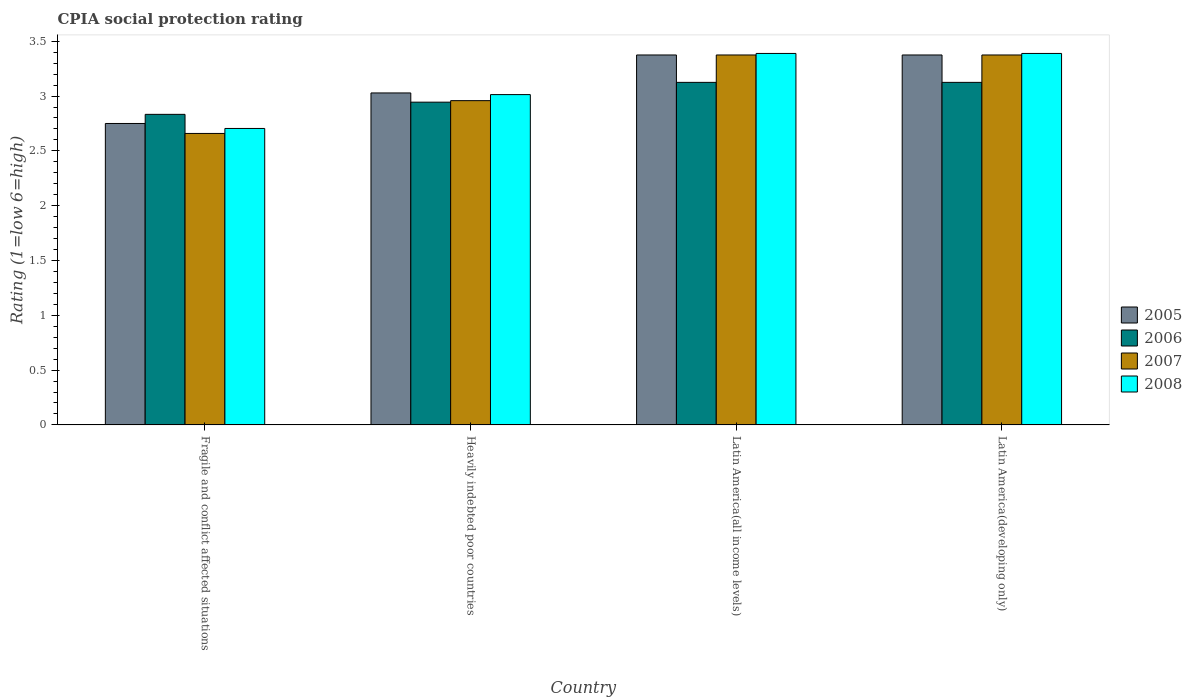How many different coloured bars are there?
Ensure brevity in your answer.  4. How many groups of bars are there?
Offer a very short reply. 4. How many bars are there on the 2nd tick from the left?
Offer a terse response. 4. What is the label of the 3rd group of bars from the left?
Provide a succinct answer. Latin America(all income levels). What is the CPIA rating in 2008 in Latin America(developing only)?
Your answer should be compact. 3.39. Across all countries, what is the maximum CPIA rating in 2006?
Offer a very short reply. 3.12. Across all countries, what is the minimum CPIA rating in 2007?
Make the answer very short. 2.66. In which country was the CPIA rating in 2008 maximum?
Give a very brief answer. Latin America(all income levels). In which country was the CPIA rating in 2007 minimum?
Provide a succinct answer. Fragile and conflict affected situations. What is the total CPIA rating in 2006 in the graph?
Provide a short and direct response. 12.03. What is the difference between the CPIA rating in 2006 in Fragile and conflict affected situations and that in Latin America(all income levels)?
Offer a terse response. -0.29. What is the difference between the CPIA rating in 2005 in Latin America(developing only) and the CPIA rating in 2006 in Heavily indebted poor countries?
Offer a terse response. 0.43. What is the average CPIA rating in 2007 per country?
Give a very brief answer. 3.09. What is the difference between the CPIA rating of/in 2008 and CPIA rating of/in 2005 in Latin America(all income levels)?
Your answer should be very brief. 0.01. What is the ratio of the CPIA rating in 2006 in Heavily indebted poor countries to that in Latin America(all income levels)?
Offer a very short reply. 0.94. Is the CPIA rating in 2007 in Fragile and conflict affected situations less than that in Latin America(all income levels)?
Ensure brevity in your answer.  Yes. Is the difference between the CPIA rating in 2008 in Fragile and conflict affected situations and Heavily indebted poor countries greater than the difference between the CPIA rating in 2005 in Fragile and conflict affected situations and Heavily indebted poor countries?
Offer a very short reply. No. What is the difference between the highest and the second highest CPIA rating in 2008?
Your answer should be compact. -0.38. What is the difference between the highest and the lowest CPIA rating in 2008?
Provide a short and direct response. 0.68. In how many countries, is the CPIA rating in 2008 greater than the average CPIA rating in 2008 taken over all countries?
Offer a terse response. 2. Is it the case that in every country, the sum of the CPIA rating in 2007 and CPIA rating in 2005 is greater than the sum of CPIA rating in 2008 and CPIA rating in 2006?
Your response must be concise. No. What does the 4th bar from the right in Heavily indebted poor countries represents?
Your response must be concise. 2005. Is it the case that in every country, the sum of the CPIA rating in 2007 and CPIA rating in 2006 is greater than the CPIA rating in 2008?
Your response must be concise. Yes. Are all the bars in the graph horizontal?
Your answer should be compact. No. Are the values on the major ticks of Y-axis written in scientific E-notation?
Give a very brief answer. No. How are the legend labels stacked?
Give a very brief answer. Vertical. What is the title of the graph?
Ensure brevity in your answer.  CPIA social protection rating. Does "1971" appear as one of the legend labels in the graph?
Provide a succinct answer. No. What is the label or title of the Y-axis?
Offer a very short reply. Rating (1=low 6=high). What is the Rating (1=low 6=high) of 2005 in Fragile and conflict affected situations?
Provide a succinct answer. 2.75. What is the Rating (1=low 6=high) in 2006 in Fragile and conflict affected situations?
Your answer should be compact. 2.83. What is the Rating (1=low 6=high) of 2007 in Fragile and conflict affected situations?
Offer a very short reply. 2.66. What is the Rating (1=low 6=high) in 2008 in Fragile and conflict affected situations?
Your answer should be very brief. 2.7. What is the Rating (1=low 6=high) in 2005 in Heavily indebted poor countries?
Offer a very short reply. 3.03. What is the Rating (1=low 6=high) in 2006 in Heavily indebted poor countries?
Give a very brief answer. 2.94. What is the Rating (1=low 6=high) of 2007 in Heavily indebted poor countries?
Give a very brief answer. 2.96. What is the Rating (1=low 6=high) of 2008 in Heavily indebted poor countries?
Keep it short and to the point. 3.01. What is the Rating (1=low 6=high) of 2005 in Latin America(all income levels)?
Keep it short and to the point. 3.38. What is the Rating (1=low 6=high) in 2006 in Latin America(all income levels)?
Offer a very short reply. 3.12. What is the Rating (1=low 6=high) in 2007 in Latin America(all income levels)?
Offer a very short reply. 3.38. What is the Rating (1=low 6=high) in 2008 in Latin America(all income levels)?
Offer a very short reply. 3.39. What is the Rating (1=low 6=high) in 2005 in Latin America(developing only)?
Your answer should be compact. 3.38. What is the Rating (1=low 6=high) of 2006 in Latin America(developing only)?
Keep it short and to the point. 3.12. What is the Rating (1=low 6=high) in 2007 in Latin America(developing only)?
Keep it short and to the point. 3.38. What is the Rating (1=low 6=high) of 2008 in Latin America(developing only)?
Offer a terse response. 3.39. Across all countries, what is the maximum Rating (1=low 6=high) in 2005?
Keep it short and to the point. 3.38. Across all countries, what is the maximum Rating (1=low 6=high) of 2006?
Your answer should be compact. 3.12. Across all countries, what is the maximum Rating (1=low 6=high) of 2007?
Your response must be concise. 3.38. Across all countries, what is the maximum Rating (1=low 6=high) of 2008?
Your answer should be very brief. 3.39. Across all countries, what is the minimum Rating (1=low 6=high) in 2005?
Your answer should be compact. 2.75. Across all countries, what is the minimum Rating (1=low 6=high) in 2006?
Offer a very short reply. 2.83. Across all countries, what is the minimum Rating (1=low 6=high) in 2007?
Keep it short and to the point. 2.66. Across all countries, what is the minimum Rating (1=low 6=high) in 2008?
Ensure brevity in your answer.  2.7. What is the total Rating (1=low 6=high) of 2005 in the graph?
Offer a very short reply. 12.53. What is the total Rating (1=low 6=high) in 2006 in the graph?
Offer a terse response. 12.03. What is the total Rating (1=low 6=high) in 2007 in the graph?
Your answer should be compact. 12.37. What is the total Rating (1=low 6=high) in 2008 in the graph?
Make the answer very short. 12.5. What is the difference between the Rating (1=low 6=high) of 2005 in Fragile and conflict affected situations and that in Heavily indebted poor countries?
Make the answer very short. -0.28. What is the difference between the Rating (1=low 6=high) of 2006 in Fragile and conflict affected situations and that in Heavily indebted poor countries?
Offer a terse response. -0.11. What is the difference between the Rating (1=low 6=high) in 2007 in Fragile and conflict affected situations and that in Heavily indebted poor countries?
Offer a terse response. -0.3. What is the difference between the Rating (1=low 6=high) in 2008 in Fragile and conflict affected situations and that in Heavily indebted poor countries?
Offer a very short reply. -0.31. What is the difference between the Rating (1=low 6=high) of 2005 in Fragile and conflict affected situations and that in Latin America(all income levels)?
Offer a terse response. -0.62. What is the difference between the Rating (1=low 6=high) in 2006 in Fragile and conflict affected situations and that in Latin America(all income levels)?
Your response must be concise. -0.29. What is the difference between the Rating (1=low 6=high) of 2007 in Fragile and conflict affected situations and that in Latin America(all income levels)?
Provide a short and direct response. -0.72. What is the difference between the Rating (1=low 6=high) of 2008 in Fragile and conflict affected situations and that in Latin America(all income levels)?
Your answer should be very brief. -0.68. What is the difference between the Rating (1=low 6=high) in 2005 in Fragile and conflict affected situations and that in Latin America(developing only)?
Your response must be concise. -0.62. What is the difference between the Rating (1=low 6=high) in 2006 in Fragile and conflict affected situations and that in Latin America(developing only)?
Your answer should be compact. -0.29. What is the difference between the Rating (1=low 6=high) in 2007 in Fragile and conflict affected situations and that in Latin America(developing only)?
Make the answer very short. -0.72. What is the difference between the Rating (1=low 6=high) in 2008 in Fragile and conflict affected situations and that in Latin America(developing only)?
Ensure brevity in your answer.  -0.68. What is the difference between the Rating (1=low 6=high) of 2005 in Heavily indebted poor countries and that in Latin America(all income levels)?
Make the answer very short. -0.35. What is the difference between the Rating (1=low 6=high) in 2006 in Heavily indebted poor countries and that in Latin America(all income levels)?
Offer a very short reply. -0.18. What is the difference between the Rating (1=low 6=high) in 2007 in Heavily indebted poor countries and that in Latin America(all income levels)?
Offer a very short reply. -0.42. What is the difference between the Rating (1=low 6=high) of 2008 in Heavily indebted poor countries and that in Latin America(all income levels)?
Give a very brief answer. -0.38. What is the difference between the Rating (1=low 6=high) of 2005 in Heavily indebted poor countries and that in Latin America(developing only)?
Your answer should be compact. -0.35. What is the difference between the Rating (1=low 6=high) of 2006 in Heavily indebted poor countries and that in Latin America(developing only)?
Keep it short and to the point. -0.18. What is the difference between the Rating (1=low 6=high) of 2007 in Heavily indebted poor countries and that in Latin America(developing only)?
Keep it short and to the point. -0.42. What is the difference between the Rating (1=low 6=high) of 2008 in Heavily indebted poor countries and that in Latin America(developing only)?
Make the answer very short. -0.38. What is the difference between the Rating (1=low 6=high) of 2008 in Latin America(all income levels) and that in Latin America(developing only)?
Keep it short and to the point. 0. What is the difference between the Rating (1=low 6=high) of 2005 in Fragile and conflict affected situations and the Rating (1=low 6=high) of 2006 in Heavily indebted poor countries?
Your response must be concise. -0.19. What is the difference between the Rating (1=low 6=high) in 2005 in Fragile and conflict affected situations and the Rating (1=low 6=high) in 2007 in Heavily indebted poor countries?
Provide a short and direct response. -0.21. What is the difference between the Rating (1=low 6=high) of 2005 in Fragile and conflict affected situations and the Rating (1=low 6=high) of 2008 in Heavily indebted poor countries?
Your answer should be very brief. -0.26. What is the difference between the Rating (1=low 6=high) of 2006 in Fragile and conflict affected situations and the Rating (1=low 6=high) of 2007 in Heavily indebted poor countries?
Offer a terse response. -0.12. What is the difference between the Rating (1=low 6=high) of 2006 in Fragile and conflict affected situations and the Rating (1=low 6=high) of 2008 in Heavily indebted poor countries?
Ensure brevity in your answer.  -0.18. What is the difference between the Rating (1=low 6=high) of 2007 in Fragile and conflict affected situations and the Rating (1=low 6=high) of 2008 in Heavily indebted poor countries?
Give a very brief answer. -0.35. What is the difference between the Rating (1=low 6=high) in 2005 in Fragile and conflict affected situations and the Rating (1=low 6=high) in 2006 in Latin America(all income levels)?
Your answer should be compact. -0.38. What is the difference between the Rating (1=low 6=high) in 2005 in Fragile and conflict affected situations and the Rating (1=low 6=high) in 2007 in Latin America(all income levels)?
Give a very brief answer. -0.62. What is the difference between the Rating (1=low 6=high) of 2005 in Fragile and conflict affected situations and the Rating (1=low 6=high) of 2008 in Latin America(all income levels)?
Your response must be concise. -0.64. What is the difference between the Rating (1=low 6=high) of 2006 in Fragile and conflict affected situations and the Rating (1=low 6=high) of 2007 in Latin America(all income levels)?
Keep it short and to the point. -0.54. What is the difference between the Rating (1=low 6=high) of 2006 in Fragile and conflict affected situations and the Rating (1=low 6=high) of 2008 in Latin America(all income levels)?
Provide a succinct answer. -0.56. What is the difference between the Rating (1=low 6=high) in 2007 in Fragile and conflict affected situations and the Rating (1=low 6=high) in 2008 in Latin America(all income levels)?
Provide a short and direct response. -0.73. What is the difference between the Rating (1=low 6=high) in 2005 in Fragile and conflict affected situations and the Rating (1=low 6=high) in 2006 in Latin America(developing only)?
Offer a very short reply. -0.38. What is the difference between the Rating (1=low 6=high) of 2005 in Fragile and conflict affected situations and the Rating (1=low 6=high) of 2007 in Latin America(developing only)?
Keep it short and to the point. -0.62. What is the difference between the Rating (1=low 6=high) in 2005 in Fragile and conflict affected situations and the Rating (1=low 6=high) in 2008 in Latin America(developing only)?
Your response must be concise. -0.64. What is the difference between the Rating (1=low 6=high) in 2006 in Fragile and conflict affected situations and the Rating (1=low 6=high) in 2007 in Latin America(developing only)?
Make the answer very short. -0.54. What is the difference between the Rating (1=low 6=high) in 2006 in Fragile and conflict affected situations and the Rating (1=low 6=high) in 2008 in Latin America(developing only)?
Ensure brevity in your answer.  -0.56. What is the difference between the Rating (1=low 6=high) in 2007 in Fragile and conflict affected situations and the Rating (1=low 6=high) in 2008 in Latin America(developing only)?
Provide a short and direct response. -0.73. What is the difference between the Rating (1=low 6=high) in 2005 in Heavily indebted poor countries and the Rating (1=low 6=high) in 2006 in Latin America(all income levels)?
Give a very brief answer. -0.1. What is the difference between the Rating (1=low 6=high) in 2005 in Heavily indebted poor countries and the Rating (1=low 6=high) in 2007 in Latin America(all income levels)?
Keep it short and to the point. -0.35. What is the difference between the Rating (1=low 6=high) in 2005 in Heavily indebted poor countries and the Rating (1=low 6=high) in 2008 in Latin America(all income levels)?
Your answer should be very brief. -0.36. What is the difference between the Rating (1=low 6=high) in 2006 in Heavily indebted poor countries and the Rating (1=low 6=high) in 2007 in Latin America(all income levels)?
Your response must be concise. -0.43. What is the difference between the Rating (1=low 6=high) of 2006 in Heavily indebted poor countries and the Rating (1=low 6=high) of 2008 in Latin America(all income levels)?
Your answer should be very brief. -0.44. What is the difference between the Rating (1=low 6=high) in 2007 in Heavily indebted poor countries and the Rating (1=low 6=high) in 2008 in Latin America(all income levels)?
Provide a short and direct response. -0.43. What is the difference between the Rating (1=low 6=high) of 2005 in Heavily indebted poor countries and the Rating (1=low 6=high) of 2006 in Latin America(developing only)?
Offer a terse response. -0.1. What is the difference between the Rating (1=low 6=high) in 2005 in Heavily indebted poor countries and the Rating (1=low 6=high) in 2007 in Latin America(developing only)?
Your answer should be compact. -0.35. What is the difference between the Rating (1=low 6=high) of 2005 in Heavily indebted poor countries and the Rating (1=low 6=high) of 2008 in Latin America(developing only)?
Offer a very short reply. -0.36. What is the difference between the Rating (1=low 6=high) of 2006 in Heavily indebted poor countries and the Rating (1=low 6=high) of 2007 in Latin America(developing only)?
Your answer should be compact. -0.43. What is the difference between the Rating (1=low 6=high) of 2006 in Heavily indebted poor countries and the Rating (1=low 6=high) of 2008 in Latin America(developing only)?
Your answer should be very brief. -0.44. What is the difference between the Rating (1=low 6=high) of 2007 in Heavily indebted poor countries and the Rating (1=low 6=high) of 2008 in Latin America(developing only)?
Give a very brief answer. -0.43. What is the difference between the Rating (1=low 6=high) in 2005 in Latin America(all income levels) and the Rating (1=low 6=high) in 2006 in Latin America(developing only)?
Provide a short and direct response. 0.25. What is the difference between the Rating (1=low 6=high) of 2005 in Latin America(all income levels) and the Rating (1=low 6=high) of 2008 in Latin America(developing only)?
Your response must be concise. -0.01. What is the difference between the Rating (1=low 6=high) of 2006 in Latin America(all income levels) and the Rating (1=low 6=high) of 2007 in Latin America(developing only)?
Your answer should be compact. -0.25. What is the difference between the Rating (1=low 6=high) of 2006 in Latin America(all income levels) and the Rating (1=low 6=high) of 2008 in Latin America(developing only)?
Your response must be concise. -0.26. What is the difference between the Rating (1=low 6=high) in 2007 in Latin America(all income levels) and the Rating (1=low 6=high) in 2008 in Latin America(developing only)?
Your answer should be compact. -0.01. What is the average Rating (1=low 6=high) of 2005 per country?
Keep it short and to the point. 3.13. What is the average Rating (1=low 6=high) in 2006 per country?
Your answer should be compact. 3.01. What is the average Rating (1=low 6=high) in 2007 per country?
Your response must be concise. 3.09. What is the average Rating (1=low 6=high) of 2008 per country?
Give a very brief answer. 3.12. What is the difference between the Rating (1=low 6=high) of 2005 and Rating (1=low 6=high) of 2006 in Fragile and conflict affected situations?
Provide a succinct answer. -0.08. What is the difference between the Rating (1=low 6=high) of 2005 and Rating (1=low 6=high) of 2007 in Fragile and conflict affected situations?
Your response must be concise. 0.09. What is the difference between the Rating (1=low 6=high) in 2005 and Rating (1=low 6=high) in 2008 in Fragile and conflict affected situations?
Ensure brevity in your answer.  0.05. What is the difference between the Rating (1=low 6=high) in 2006 and Rating (1=low 6=high) in 2007 in Fragile and conflict affected situations?
Provide a short and direct response. 0.17. What is the difference between the Rating (1=low 6=high) in 2006 and Rating (1=low 6=high) in 2008 in Fragile and conflict affected situations?
Your answer should be compact. 0.13. What is the difference between the Rating (1=low 6=high) in 2007 and Rating (1=low 6=high) in 2008 in Fragile and conflict affected situations?
Provide a succinct answer. -0.05. What is the difference between the Rating (1=low 6=high) in 2005 and Rating (1=low 6=high) in 2006 in Heavily indebted poor countries?
Your response must be concise. 0.08. What is the difference between the Rating (1=low 6=high) in 2005 and Rating (1=low 6=high) in 2007 in Heavily indebted poor countries?
Offer a terse response. 0.07. What is the difference between the Rating (1=low 6=high) of 2005 and Rating (1=low 6=high) of 2008 in Heavily indebted poor countries?
Provide a short and direct response. 0.02. What is the difference between the Rating (1=low 6=high) in 2006 and Rating (1=low 6=high) in 2007 in Heavily indebted poor countries?
Offer a terse response. -0.01. What is the difference between the Rating (1=low 6=high) in 2006 and Rating (1=low 6=high) in 2008 in Heavily indebted poor countries?
Make the answer very short. -0.07. What is the difference between the Rating (1=low 6=high) of 2007 and Rating (1=low 6=high) of 2008 in Heavily indebted poor countries?
Provide a short and direct response. -0.06. What is the difference between the Rating (1=low 6=high) in 2005 and Rating (1=low 6=high) in 2007 in Latin America(all income levels)?
Your answer should be compact. 0. What is the difference between the Rating (1=low 6=high) in 2005 and Rating (1=low 6=high) in 2008 in Latin America(all income levels)?
Keep it short and to the point. -0.01. What is the difference between the Rating (1=low 6=high) in 2006 and Rating (1=low 6=high) in 2007 in Latin America(all income levels)?
Offer a very short reply. -0.25. What is the difference between the Rating (1=low 6=high) in 2006 and Rating (1=low 6=high) in 2008 in Latin America(all income levels)?
Offer a very short reply. -0.26. What is the difference between the Rating (1=low 6=high) in 2007 and Rating (1=low 6=high) in 2008 in Latin America(all income levels)?
Make the answer very short. -0.01. What is the difference between the Rating (1=low 6=high) of 2005 and Rating (1=low 6=high) of 2006 in Latin America(developing only)?
Your response must be concise. 0.25. What is the difference between the Rating (1=low 6=high) of 2005 and Rating (1=low 6=high) of 2007 in Latin America(developing only)?
Your answer should be very brief. 0. What is the difference between the Rating (1=low 6=high) of 2005 and Rating (1=low 6=high) of 2008 in Latin America(developing only)?
Offer a very short reply. -0.01. What is the difference between the Rating (1=low 6=high) in 2006 and Rating (1=low 6=high) in 2007 in Latin America(developing only)?
Keep it short and to the point. -0.25. What is the difference between the Rating (1=low 6=high) in 2006 and Rating (1=low 6=high) in 2008 in Latin America(developing only)?
Give a very brief answer. -0.26. What is the difference between the Rating (1=low 6=high) in 2007 and Rating (1=low 6=high) in 2008 in Latin America(developing only)?
Give a very brief answer. -0.01. What is the ratio of the Rating (1=low 6=high) in 2005 in Fragile and conflict affected situations to that in Heavily indebted poor countries?
Make the answer very short. 0.91. What is the ratio of the Rating (1=low 6=high) of 2006 in Fragile and conflict affected situations to that in Heavily indebted poor countries?
Your answer should be very brief. 0.96. What is the ratio of the Rating (1=low 6=high) of 2007 in Fragile and conflict affected situations to that in Heavily indebted poor countries?
Make the answer very short. 0.9. What is the ratio of the Rating (1=low 6=high) in 2008 in Fragile and conflict affected situations to that in Heavily indebted poor countries?
Provide a succinct answer. 0.9. What is the ratio of the Rating (1=low 6=high) of 2005 in Fragile and conflict affected situations to that in Latin America(all income levels)?
Keep it short and to the point. 0.81. What is the ratio of the Rating (1=low 6=high) in 2006 in Fragile and conflict affected situations to that in Latin America(all income levels)?
Offer a very short reply. 0.91. What is the ratio of the Rating (1=low 6=high) in 2007 in Fragile and conflict affected situations to that in Latin America(all income levels)?
Offer a very short reply. 0.79. What is the ratio of the Rating (1=low 6=high) of 2008 in Fragile and conflict affected situations to that in Latin America(all income levels)?
Keep it short and to the point. 0.8. What is the ratio of the Rating (1=low 6=high) in 2005 in Fragile and conflict affected situations to that in Latin America(developing only)?
Your answer should be very brief. 0.81. What is the ratio of the Rating (1=low 6=high) of 2006 in Fragile and conflict affected situations to that in Latin America(developing only)?
Make the answer very short. 0.91. What is the ratio of the Rating (1=low 6=high) of 2007 in Fragile and conflict affected situations to that in Latin America(developing only)?
Ensure brevity in your answer.  0.79. What is the ratio of the Rating (1=low 6=high) of 2008 in Fragile and conflict affected situations to that in Latin America(developing only)?
Make the answer very short. 0.8. What is the ratio of the Rating (1=low 6=high) of 2005 in Heavily indebted poor countries to that in Latin America(all income levels)?
Give a very brief answer. 0.9. What is the ratio of the Rating (1=low 6=high) in 2006 in Heavily indebted poor countries to that in Latin America(all income levels)?
Provide a succinct answer. 0.94. What is the ratio of the Rating (1=low 6=high) in 2007 in Heavily indebted poor countries to that in Latin America(all income levels)?
Your answer should be compact. 0.88. What is the ratio of the Rating (1=low 6=high) of 2008 in Heavily indebted poor countries to that in Latin America(all income levels)?
Your response must be concise. 0.89. What is the ratio of the Rating (1=low 6=high) of 2005 in Heavily indebted poor countries to that in Latin America(developing only)?
Make the answer very short. 0.9. What is the ratio of the Rating (1=low 6=high) of 2006 in Heavily indebted poor countries to that in Latin America(developing only)?
Keep it short and to the point. 0.94. What is the ratio of the Rating (1=low 6=high) of 2007 in Heavily indebted poor countries to that in Latin America(developing only)?
Keep it short and to the point. 0.88. What is the ratio of the Rating (1=low 6=high) of 2008 in Heavily indebted poor countries to that in Latin America(developing only)?
Keep it short and to the point. 0.89. What is the ratio of the Rating (1=low 6=high) of 2007 in Latin America(all income levels) to that in Latin America(developing only)?
Your answer should be very brief. 1. What is the ratio of the Rating (1=low 6=high) in 2008 in Latin America(all income levels) to that in Latin America(developing only)?
Provide a succinct answer. 1. What is the difference between the highest and the second highest Rating (1=low 6=high) in 2007?
Provide a succinct answer. 0. What is the difference between the highest and the lowest Rating (1=low 6=high) in 2005?
Make the answer very short. 0.62. What is the difference between the highest and the lowest Rating (1=low 6=high) of 2006?
Your response must be concise. 0.29. What is the difference between the highest and the lowest Rating (1=low 6=high) in 2007?
Your answer should be compact. 0.72. What is the difference between the highest and the lowest Rating (1=low 6=high) in 2008?
Give a very brief answer. 0.68. 